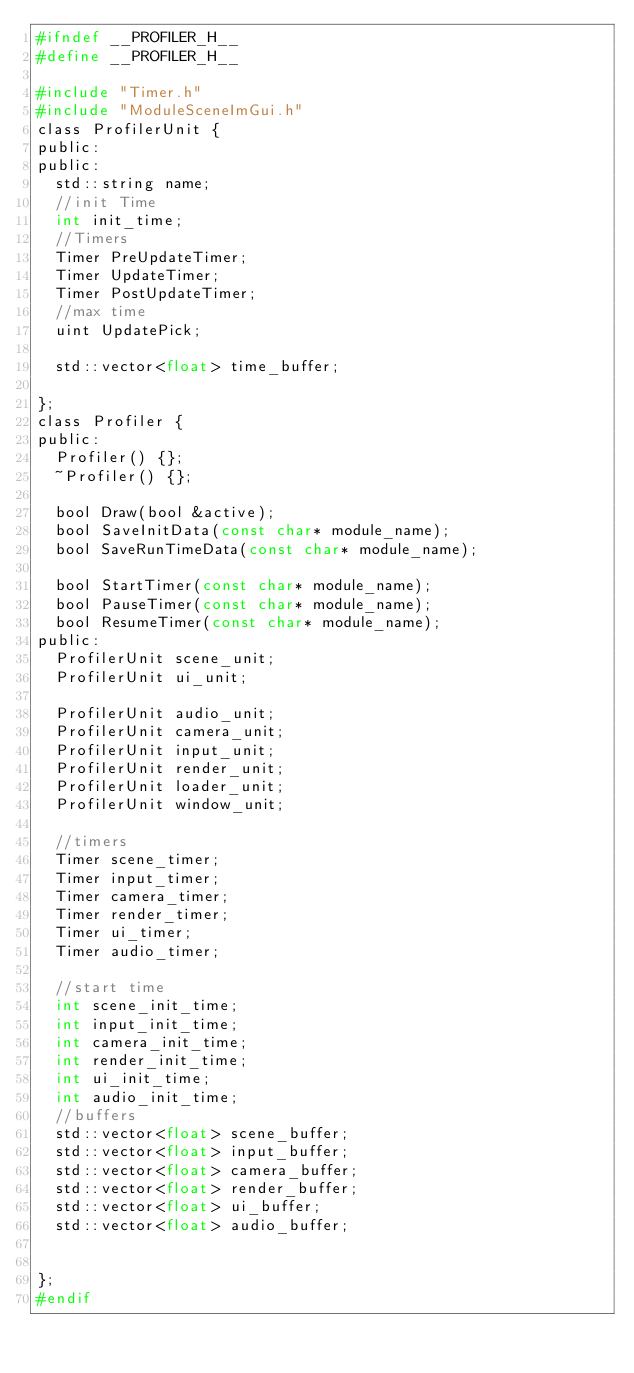Convert code to text. <code><loc_0><loc_0><loc_500><loc_500><_C_>#ifndef __PROFILER_H__
#define __PROFILER_H__

#include "Timer.h"
#include "ModuleSceneImGui.h"
class ProfilerUnit {
public:
public:
	std::string name;
	//init Time
	int init_time;
	//Timers
	Timer PreUpdateTimer;
	Timer UpdateTimer;
	Timer PostUpdateTimer;
	//max time
	uint UpdatePick;

	std::vector<float> time_buffer;

};
class Profiler {
public:
	Profiler() {};
	~Profiler() {};

	bool Draw(bool &active);
	bool SaveInitData(const char* module_name);
	bool SaveRunTimeData(const char* module_name);

	bool StartTimer(const char* module_name);
	bool PauseTimer(const char* module_name);
	bool ResumeTimer(const char* module_name);
public:
	ProfilerUnit scene_unit;
	ProfilerUnit ui_unit;

	ProfilerUnit audio_unit;
	ProfilerUnit camera_unit;
	ProfilerUnit input_unit;
	ProfilerUnit render_unit;
	ProfilerUnit loader_unit;
	ProfilerUnit window_unit;

	//timers
	Timer scene_timer;
	Timer input_timer;
	Timer camera_timer;
	Timer render_timer;
	Timer ui_timer;
	Timer audio_timer;
	
	//start time
	int scene_init_time;
	int input_init_time;
	int camera_init_time;
	int render_init_time;
	int ui_init_time;
	int audio_init_time;
	//buffers
	std::vector<float> scene_buffer;
	std::vector<float> input_buffer;
	std::vector<float> camera_buffer;
	std::vector<float> render_buffer;
	std::vector<float> ui_buffer;
	std::vector<float> audio_buffer;


};
#endif</code> 